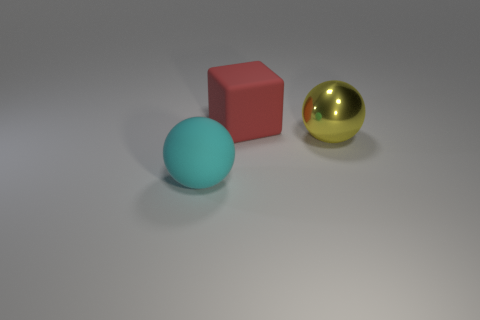Subtract all spheres. How many objects are left? 1 Subtract 1 balls. How many balls are left? 1 Subtract all yellow balls. How many balls are left? 1 Subtract 1 red blocks. How many objects are left? 2 Subtract all brown spheres. Subtract all purple cylinders. How many spheres are left? 2 Subtract all yellow cubes. How many brown balls are left? 0 Subtract all red rubber things. Subtract all yellow balls. How many objects are left? 1 Add 2 cyan objects. How many cyan objects are left? 3 Add 2 large blocks. How many large blocks exist? 3 Add 3 large metallic things. How many objects exist? 6 